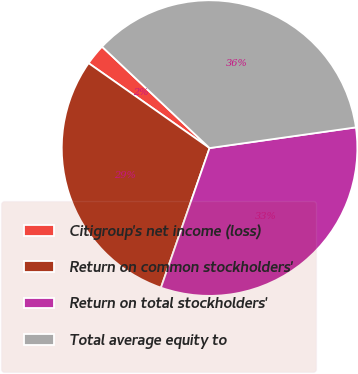Convert chart. <chart><loc_0><loc_0><loc_500><loc_500><pie_chart><fcel>Citigroup's net income (loss)<fcel>Return on common stockholders'<fcel>Return on total stockholders'<fcel>Total average equity to<nl><fcel>2.29%<fcel>29.41%<fcel>32.57%<fcel>35.73%<nl></chart> 